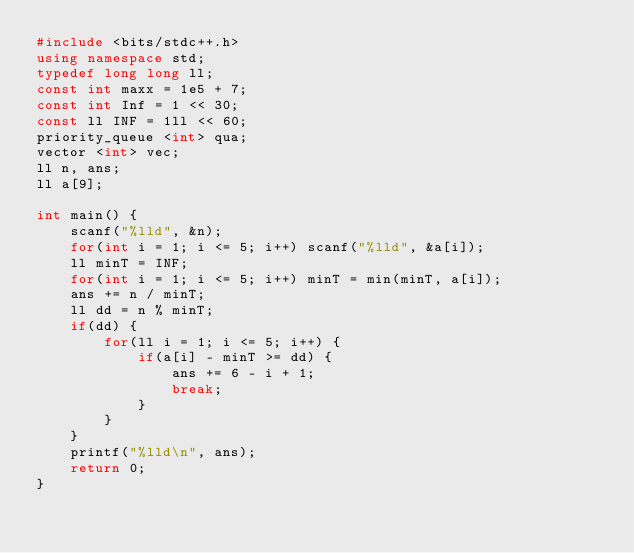Convert code to text. <code><loc_0><loc_0><loc_500><loc_500><_C++_>#include <bits/stdc++.h>
using namespace std;
typedef long long ll;
const int maxx = 1e5 + 7;
const int Inf = 1 << 30;
const ll INF = 1ll << 60;
priority_queue <int> qua;
vector <int> vec;
ll n, ans;
ll a[9];

int main() {
	scanf("%lld", &n);
	for(int i = 1; i <= 5; i++) scanf("%lld", &a[i]);
	ll minT = INF;
	for(int i = 1; i <= 5; i++) minT = min(minT, a[i]);
	ans += n / minT;
	ll dd = n % minT;
	if(dd) {
		for(ll i = 1; i <= 5; i++) {
			if(a[i] - minT >= dd) {
				ans += 6 - i + 1;
				break;
			}
		}
	}
	printf("%lld\n", ans);
	return 0;
}</code> 